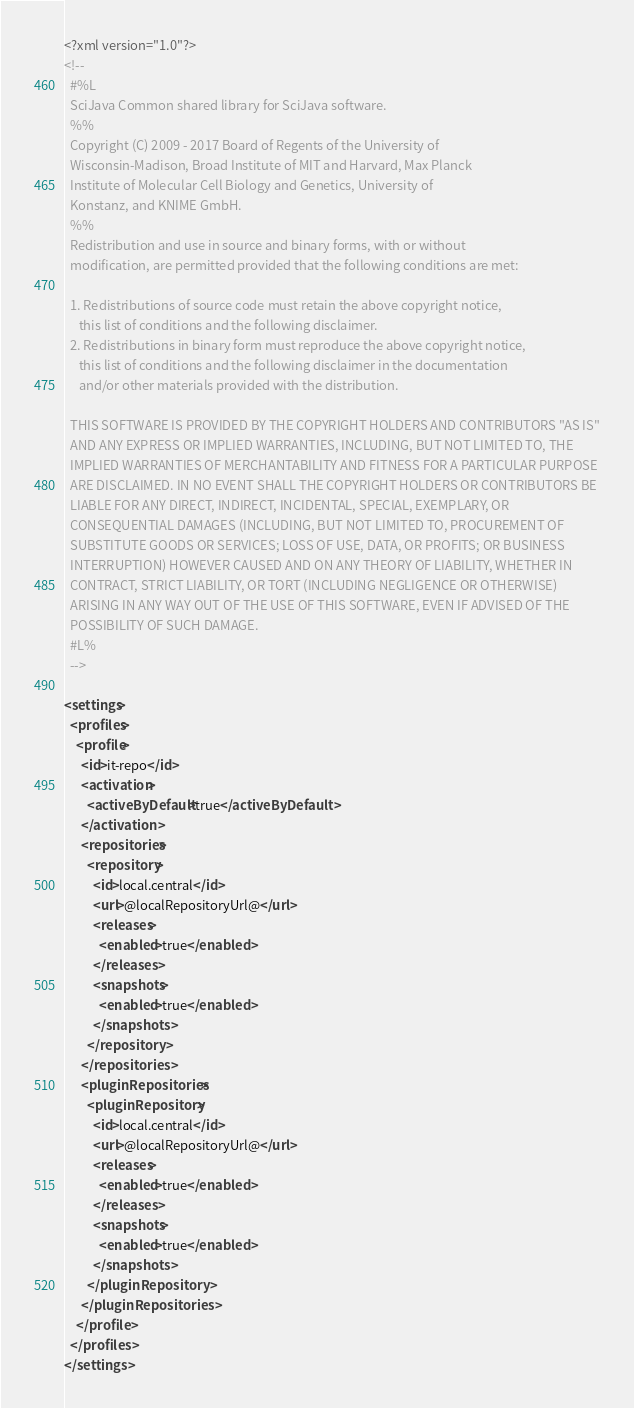<code> <loc_0><loc_0><loc_500><loc_500><_XML_><?xml version="1.0"?>
<!--
  #%L
  SciJava Common shared library for SciJava software.
  %%
  Copyright (C) 2009 - 2017 Board of Regents of the University of
  Wisconsin-Madison, Broad Institute of MIT and Harvard, Max Planck
  Institute of Molecular Cell Biology and Genetics, University of
  Konstanz, and KNIME GmbH.
  %%
  Redistribution and use in source and binary forms, with or without
  modification, are permitted provided that the following conditions are met:
  
  1. Redistributions of source code must retain the above copyright notice,
     this list of conditions and the following disclaimer.
  2. Redistributions in binary form must reproduce the above copyright notice,
     this list of conditions and the following disclaimer in the documentation
     and/or other materials provided with the distribution.
  
  THIS SOFTWARE IS PROVIDED BY THE COPYRIGHT HOLDERS AND CONTRIBUTORS "AS IS"
  AND ANY EXPRESS OR IMPLIED WARRANTIES, INCLUDING, BUT NOT LIMITED TO, THE
  IMPLIED WARRANTIES OF MERCHANTABILITY AND FITNESS FOR A PARTICULAR PURPOSE
  ARE DISCLAIMED. IN NO EVENT SHALL THE COPYRIGHT HOLDERS OR CONTRIBUTORS BE
  LIABLE FOR ANY DIRECT, INDIRECT, INCIDENTAL, SPECIAL, EXEMPLARY, OR
  CONSEQUENTIAL DAMAGES (INCLUDING, BUT NOT LIMITED TO, PROCUREMENT OF
  SUBSTITUTE GOODS OR SERVICES; LOSS OF USE, DATA, OR PROFITS; OR BUSINESS
  INTERRUPTION) HOWEVER CAUSED AND ON ANY THEORY OF LIABILITY, WHETHER IN
  CONTRACT, STRICT LIABILITY, OR TORT (INCLUDING NEGLIGENCE OR OTHERWISE)
  ARISING IN ANY WAY OUT OF THE USE OF THIS SOFTWARE, EVEN IF ADVISED OF THE
  POSSIBILITY OF SUCH DAMAGE.
  #L%
  -->

<settings>
  <profiles>
    <profile>
      <id>it-repo</id>
      <activation>
        <activeByDefault>true</activeByDefault>
      </activation>
      <repositories>
        <repository>
          <id>local.central</id>
          <url>@localRepositoryUrl@</url>
          <releases>
            <enabled>true</enabled>
          </releases>
          <snapshots>
            <enabled>true</enabled>
          </snapshots>
        </repository>
      </repositories>
      <pluginRepositories>
        <pluginRepository>
          <id>local.central</id>
          <url>@localRepositoryUrl@</url>
          <releases>
            <enabled>true</enabled>
          </releases>
          <snapshots>
            <enabled>true</enabled>
          </snapshots>
        </pluginRepository>
      </pluginRepositories>
    </profile>
  </profiles>
</settings>
</code> 